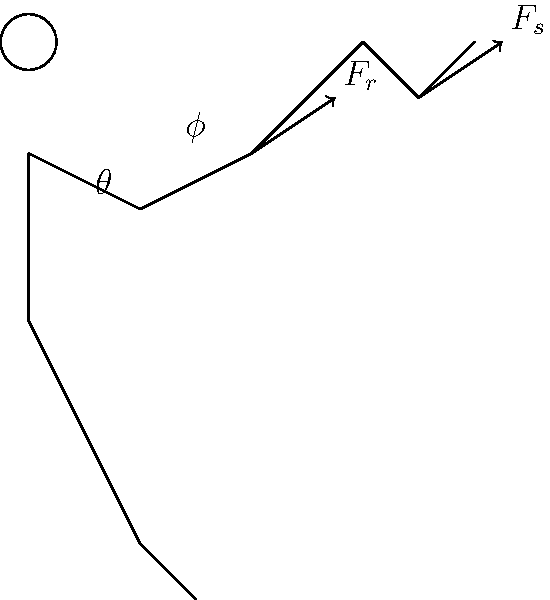In a badminton serve, the player's arm forms an angle $\theta$ with the vertical at the elbow, and the racket forms an angle $\phi$ with the forearm at the wrist. If the force applied by the racket to the shuttlecock ($F_s$) is directly proportional to the force applied by the arm to the racket ($F_r$), how would increasing the angle $\theta$ while keeping $\phi$ constant affect the force transferred to the shuttlecock? To understand how increasing the angle $\theta$ affects the force transferred to the shuttlecock, let's break it down step-by-step:

1. The force applied by the arm to the racket ($F_r$) is transmitted through a series of joints: shoulder, elbow, and wrist.

2. The angle $\theta$ represents the angle between the upper arm and the vertical axis. As this angle increases, it affects the leverage of the arm.

3. In biomechanics, the principle of moment arms applies. The moment arm is the perpendicular distance from the joint axis to the line of action of the force.

4. When $\theta$ increases, the moment arm of the force applied by the upper arm increases, potentially leading to a greater torque at the elbow joint.

5. This increased torque at the elbow can result in a higher angular velocity of the forearm.

6. Since the angle $\phi$ (between the forearm and racket) remains constant, the increased angular velocity of the forearm directly translates to a higher linear velocity of the racket head.

7. The force applied by the racket to the shuttlecock ($F_s$) is related to the racket's velocity at impact. In simple terms: $F_s \propto v^2$, where $v$ is the velocity of the racket head.

8. Therefore, if the velocity of the racket head increases due to the larger $\theta$, the force applied to the shuttlecock ($F_s$) will increase quadratically.

9. Given that $F_s$ is directly proportional to $F_r$, we can conclude that increasing $\theta$ while keeping $\phi$ constant would result in an increase in the force transferred to the shuttlecock.
Answer: Increasing $\theta$ increases the force transferred to the shuttlecock. 